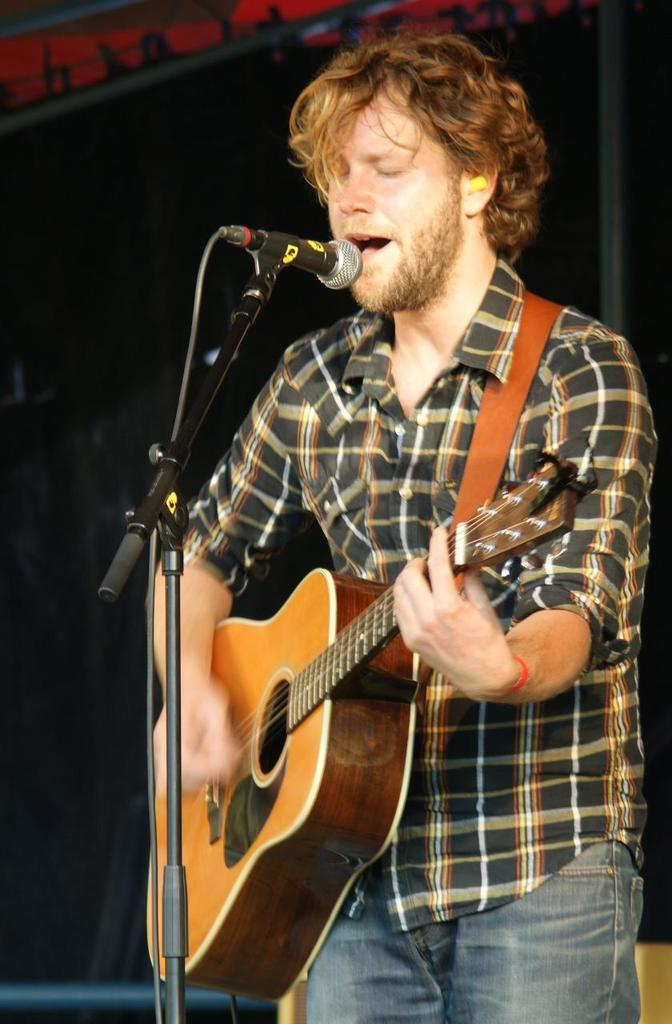What is the person in the image doing? The person is playing a guitar and singing. What type of clothing is the person wearing? The person is wearing a shirt and jeans. What object is the person using to amplify their voice? There is a microphone in the image. What type of fruit is the person holding in the image? There is no fruit visible in the image; the person is holding a guitar. How does the person plan to use the quilt in the image? There is no quilt present in the image. 